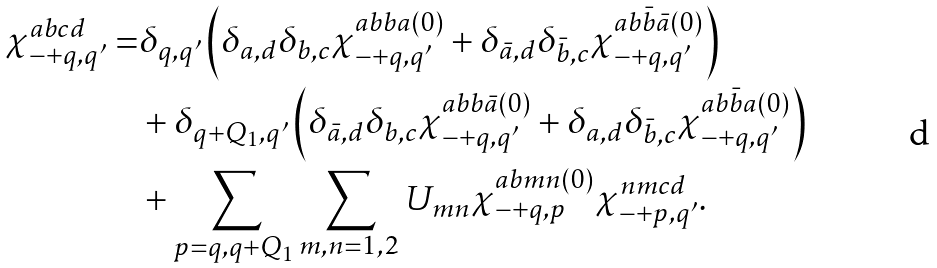Convert formula to latex. <formula><loc_0><loc_0><loc_500><loc_500>\chi ^ { a b c d } _ { - + q , q ^ { \prime } } = & \delta _ { q , q ^ { \prime } } \left ( \delta _ { a , d } \delta _ { b , c } \chi ^ { a b b a ( 0 ) } _ { - + q , q ^ { \prime } } + \delta _ { \bar { a } , d } \delta _ { \bar { b } , c } \chi ^ { a b \bar { b } \bar { a } ( 0 ) } _ { - + q , q ^ { \prime } } \right ) \\ & + \delta _ { q + Q _ { 1 } , q ^ { \prime } } \left ( \delta _ { \bar { a } , d } \delta _ { b , c } \chi ^ { a b b \bar { a } ( 0 ) } _ { - + q , q ^ { \prime } } + \delta _ { a , d } \delta _ { \bar { b } , c } \chi ^ { a b \bar { b } a ( 0 ) } _ { - + q , q ^ { \prime } } \right ) \\ & + \sum _ { p = q , q + Q _ { 1 } } \sum _ { m , n = 1 , 2 } U _ { m n } \chi ^ { a b m n ( 0 ) } _ { - + q , p } \chi ^ { n m c d } _ { - + p , q ^ { \prime } } .</formula> 